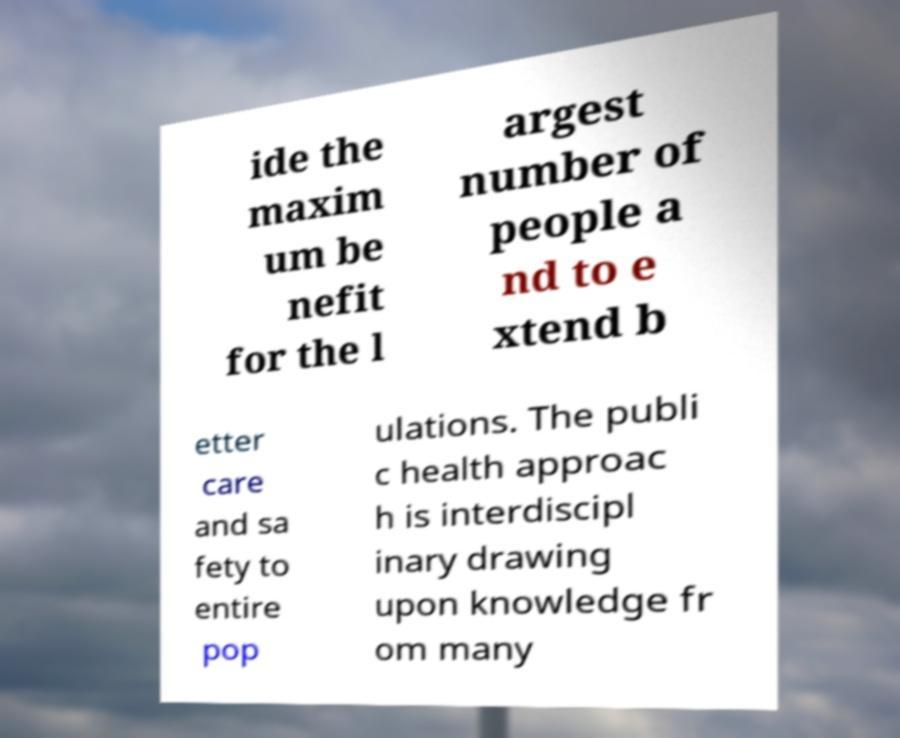For documentation purposes, I need the text within this image transcribed. Could you provide that? ide the maxim um be nefit for the l argest number of people a nd to e xtend b etter care and sa fety to entire pop ulations. The publi c health approac h is interdiscipl inary drawing upon knowledge fr om many 